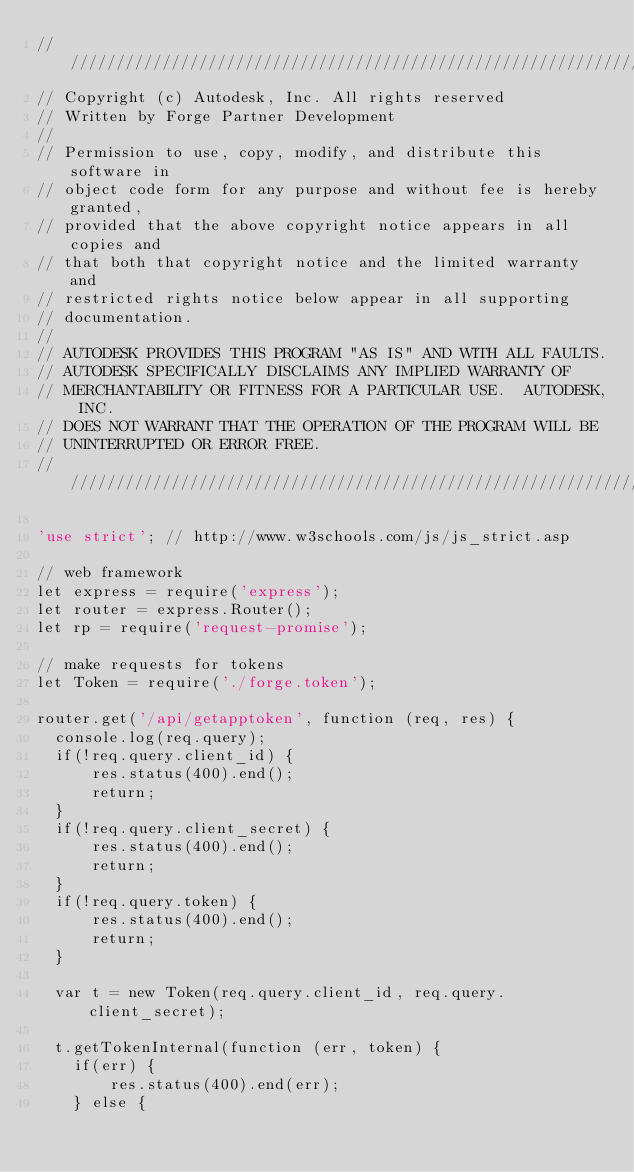Convert code to text. <code><loc_0><loc_0><loc_500><loc_500><_JavaScript_>/////////////////////////////////////////////////////////////////////
// Copyright (c) Autodesk, Inc. All rights reserved
// Written by Forge Partner Development
//
// Permission to use, copy, modify, and distribute this software in
// object code form for any purpose and without fee is hereby granted,
// provided that the above copyright notice appears in all copies and
// that both that copyright notice and the limited warranty and
// restricted rights notice below appear in all supporting
// documentation.
//
// AUTODESK PROVIDES THIS PROGRAM "AS IS" AND WITH ALL FAULTS.
// AUTODESK SPECIFICALLY DISCLAIMS ANY IMPLIED WARRANTY OF
// MERCHANTABILITY OR FITNESS FOR A PARTICULAR USE.  AUTODESK, INC.
// DOES NOT WARRANT THAT THE OPERATION OF THE PROGRAM WILL BE
// UNINTERRUPTED OR ERROR FREE.
/////////////////////////////////////////////////////////////////////

'use strict'; // http://www.w3schools.com/js/js_strict.asp

// web framework
let express = require('express');
let router = express.Router();
let rp = require('request-promise');

// make requests for tokens
let Token = require('./forge.token');

router.get('/api/getapptoken', function (req, res) {
  console.log(req.query);
  if(!req.query.client_id) {
      res.status(400).end();
      return;
  }
  if(!req.query.client_secret) {
      res.status(400).end();
      return;
  }
  if(!req.query.token) {
      res.status(400).end();
      return;
  }

  var t = new Token(req.query.client_id, req.query.client_secret);

  t.getTokenInternal(function (err, token) {
    if(err) {
        res.status(400).end(err);
    } else {</code> 